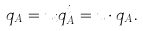Convert formula to latex. <formula><loc_0><loc_0><loc_500><loc_500>q _ { A } = u _ { i } q _ { A } ^ { i } = { u } \cdot { q } _ { A } .</formula> 